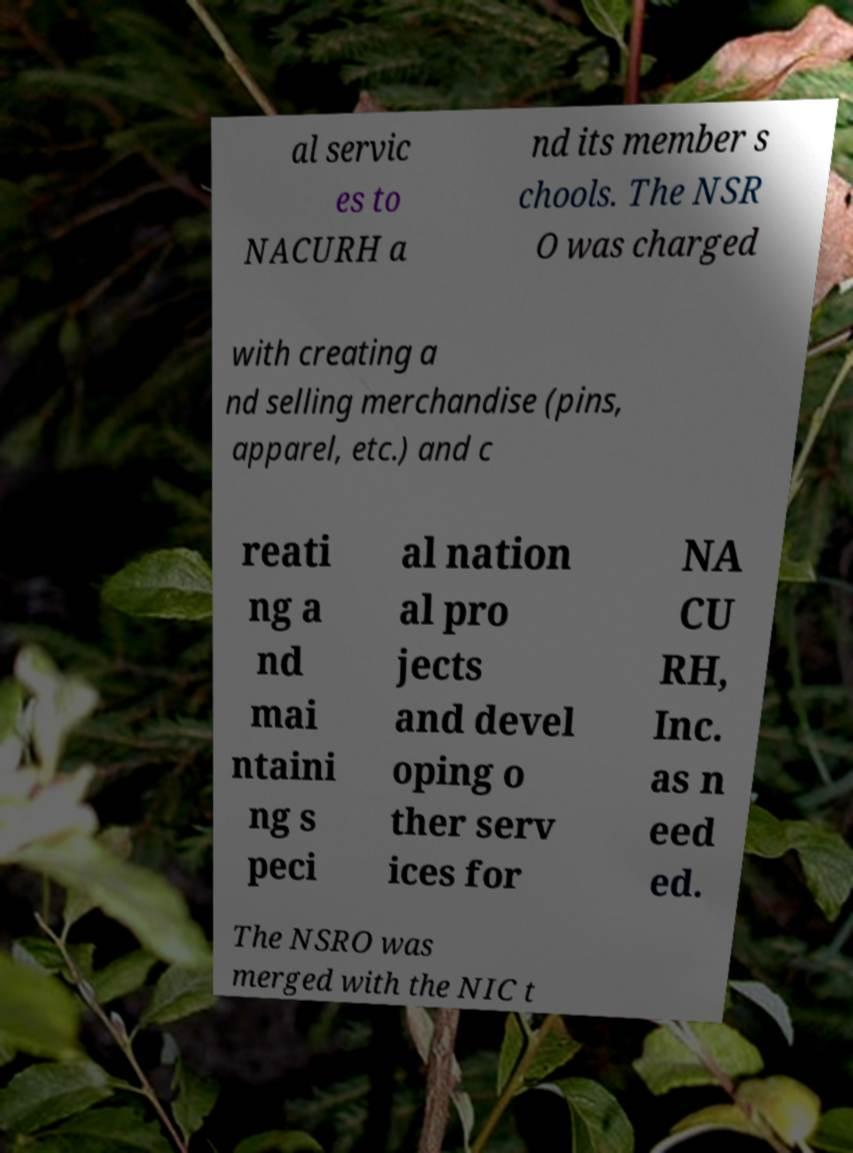I need the written content from this picture converted into text. Can you do that? al servic es to NACURH a nd its member s chools. The NSR O was charged with creating a nd selling merchandise (pins, apparel, etc.) and c reati ng a nd mai ntaini ng s peci al nation al pro jects and devel oping o ther serv ices for NA CU RH, Inc. as n eed ed. The NSRO was merged with the NIC t 